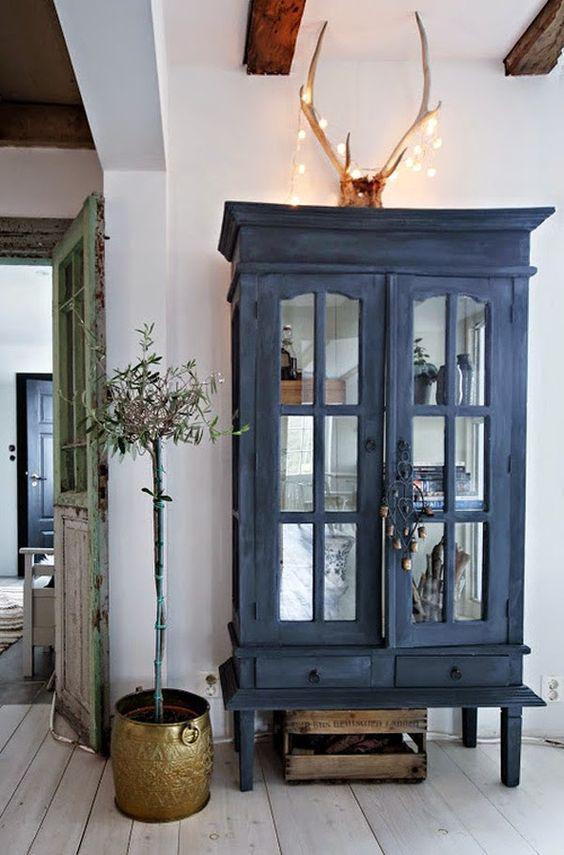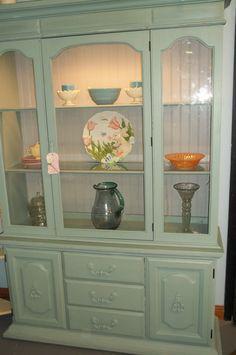The first image is the image on the left, the second image is the image on the right. Evaluate the accuracy of this statement regarding the images: "There is a plant on the side of the cabinet in the image on the left.". Is it true? Answer yes or no. Yes. 